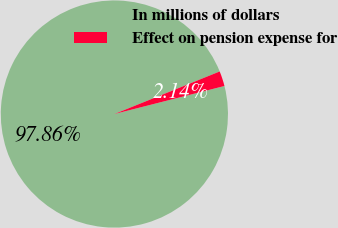<chart> <loc_0><loc_0><loc_500><loc_500><pie_chart><fcel>In millions of dollars<fcel>Effect on pension expense for<nl><fcel>97.86%<fcel>2.14%<nl></chart> 